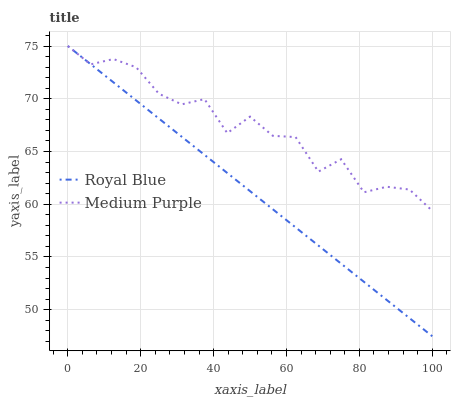Does Royal Blue have the minimum area under the curve?
Answer yes or no. Yes. Does Medium Purple have the maximum area under the curve?
Answer yes or no. Yes. Does Royal Blue have the maximum area under the curve?
Answer yes or no. No. Is Royal Blue the smoothest?
Answer yes or no. Yes. Is Medium Purple the roughest?
Answer yes or no. Yes. Is Royal Blue the roughest?
Answer yes or no. No. Does Royal Blue have the lowest value?
Answer yes or no. Yes. Does Royal Blue have the highest value?
Answer yes or no. Yes. Does Medium Purple intersect Royal Blue?
Answer yes or no. Yes. Is Medium Purple less than Royal Blue?
Answer yes or no. No. Is Medium Purple greater than Royal Blue?
Answer yes or no. No. 